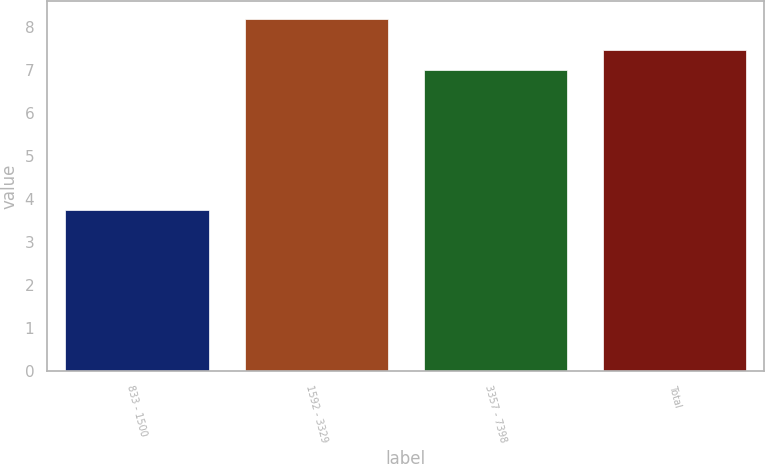<chart> <loc_0><loc_0><loc_500><loc_500><bar_chart><fcel>833 - 1500<fcel>1592 - 3329<fcel>3357 - 7398<fcel>Total<nl><fcel>3.75<fcel>8.2<fcel>7.01<fcel>7.46<nl></chart> 